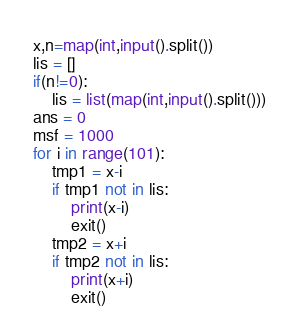<code> <loc_0><loc_0><loc_500><loc_500><_Python_>x,n=map(int,input().split())
lis = []
if(n!=0):
    lis = list(map(int,input().split()))
ans = 0
msf = 1000
for i in range(101):
    tmp1 = x-i
    if tmp1 not in lis:
        print(x-i)
        exit()
    tmp2 = x+i
    if tmp2 not in lis:
        print(x+i)
        exit()</code> 